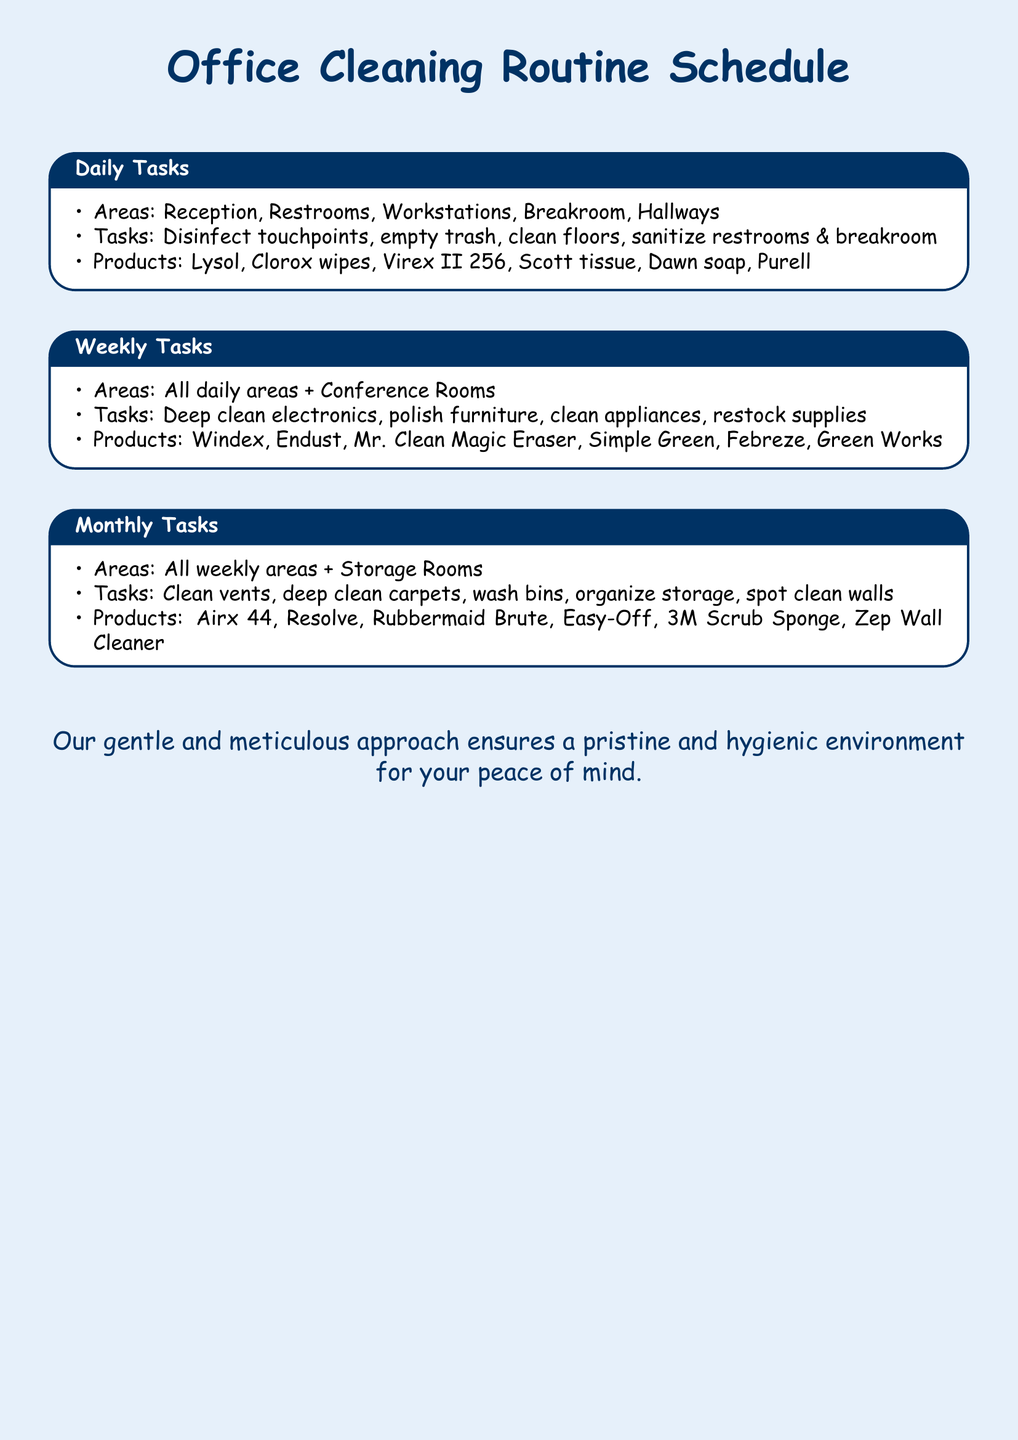What are the daily areas covered? The daily areas covered include Reception, Restrooms, Workstations, Breakroom, and Hallways.
Answer: Reception, Restrooms, Workstations, Breakroom, Hallways How often are appliances cleaned? Appliances are cleaned on a weekly basis as part of the cleaning routine.
Answer: Weekly What product is used to disinfect touchpoints daily? The product used for disinfecting touchpoints daily is Lysol.
Answer: Lysol What is one task performed monthly? One task performed monthly is to clean vents.
Answer: Clean vents Which area is added during the weekly cleaning tasks? The area added during the weekly cleaning tasks is Conference Rooms.
Answer: Conference Rooms What is the purpose of the hygiene products listed? The hygiene products listed are used to maintain cleanliness and sanitation in the office.
Answer: Cleanliness and sanitation How many specific products are mentioned for daily tasks? There are six specific products mentioned for daily tasks.
Answer: Six What is the product used for deep cleaning carpets monthly? The product used for deep cleaning carpets monthly is Resolve.
Answer: Resolve What is the title of the document? The title of the document is "Office Cleaning Routine Schedule."
Answer: Office Cleaning Routine Schedule 